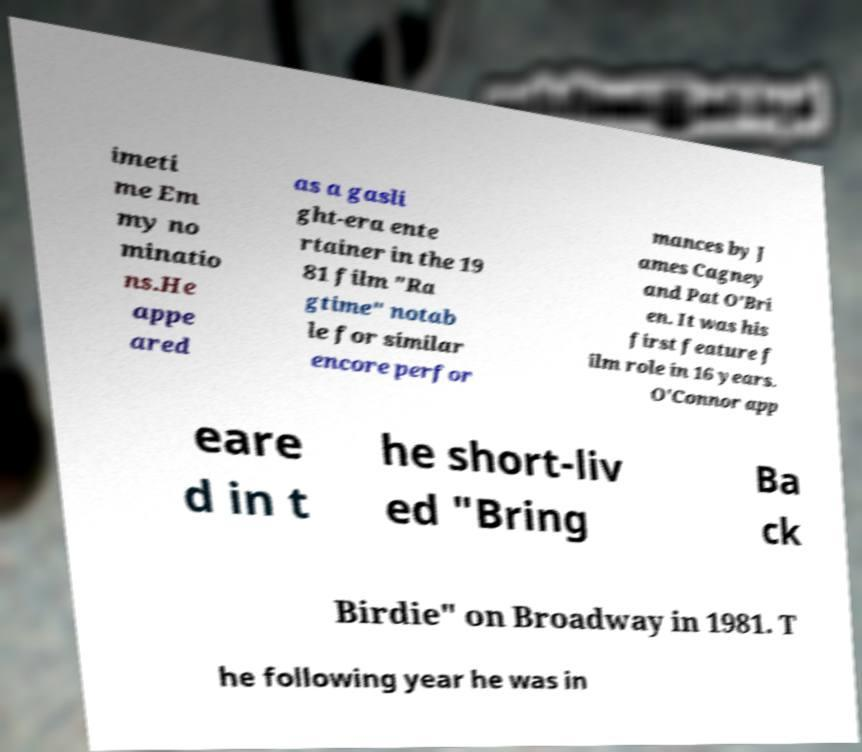What messages or text are displayed in this image? I need them in a readable, typed format. imeti me Em my no minatio ns.He appe ared as a gasli ght-era ente rtainer in the 19 81 film "Ra gtime" notab le for similar encore perfor mances by J ames Cagney and Pat O'Bri en. It was his first feature f ilm role in 16 years. O'Connor app eare d in t he short-liv ed "Bring Ba ck Birdie" on Broadway in 1981. T he following year he was in 